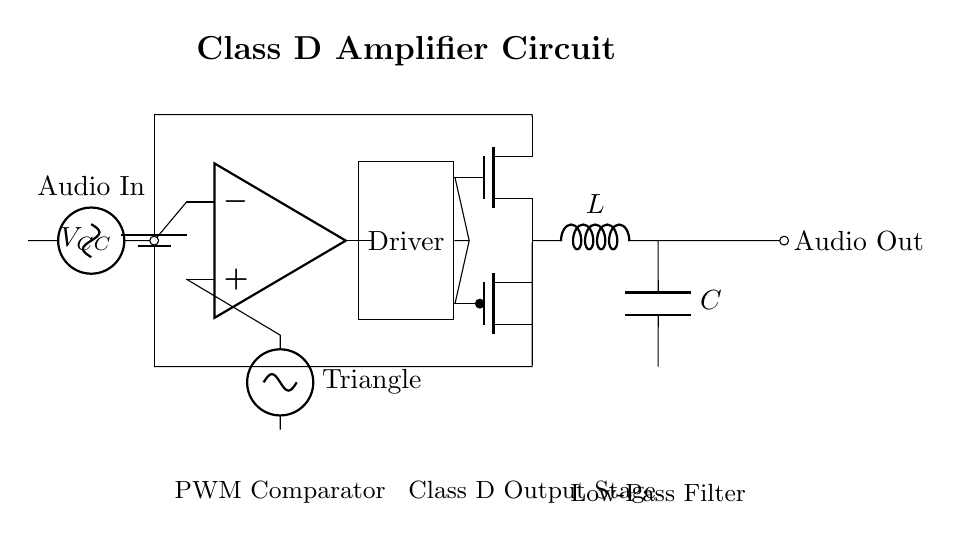What is the function of the PWM comparator? The PWM comparator generates a pulse-width modulated signal based on the audio input and a triangular reference signal, which helps to modulate the power delivery to the MOSFETs.
Answer: PWM modulation What type of transistors are used in the output stage? The output stage employs an NMOS and a PMOS transistor for efficient switching, which are crucial for enabling the Class D amplifier to operate in a high-efficiency mode.
Answer: NMOS and PMOS What component is responsible for filtering the output signal? The low-pass filter composed of an inductor and a capacitor smooths out the PWM signal and delivers a clean output audio signal to the speaker.
Answer: Inductor and capacitor What is the role of the battery in the circuit? The battery provides the power supply voltage \( V_{CC} \), which is necessary for the amplifier and all its components to operate effectively.
Answer: Power supply What is the signal labeled as "Audio In"? The "Audio In" label signifies the input audio signal that the amplifier circuit is designed to amplify, which is typically a small audio voltage that needs boosting.
Answer: Input audio signal How does the output stage achieve high efficiency? The output stage uses switching transistors to rapidly turn on and off, allowing for minimal power loss during operation and overall higher efficiency in audio amplification.
Answer: Switching transistors 